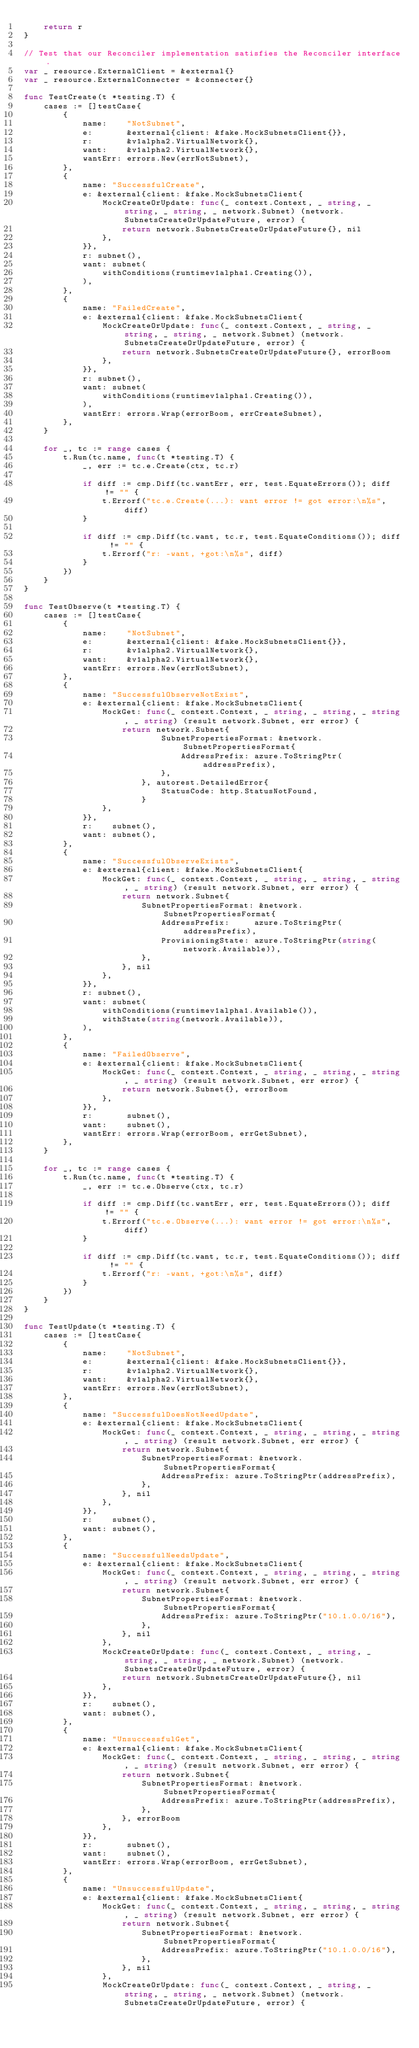Convert code to text. <code><loc_0><loc_0><loc_500><loc_500><_Go_>	return r
}

// Test that our Reconciler implementation satisfies the Reconciler interface.
var _ resource.ExternalClient = &external{}
var _ resource.ExternalConnecter = &connecter{}

func TestCreate(t *testing.T) {
	cases := []testCase{
		{
			name:    "NotSubnet",
			e:       &external{client: &fake.MockSubnetsClient{}},
			r:       &v1alpha2.VirtualNetwork{},
			want:    &v1alpha2.VirtualNetwork{},
			wantErr: errors.New(errNotSubnet),
		},
		{
			name: "SuccessfulCreate",
			e: &external{client: &fake.MockSubnetsClient{
				MockCreateOrUpdate: func(_ context.Context, _ string, _ string, _ string, _ network.Subnet) (network.SubnetsCreateOrUpdateFuture, error) {
					return network.SubnetsCreateOrUpdateFuture{}, nil
				},
			}},
			r: subnet(),
			want: subnet(
				withConditions(runtimev1alpha1.Creating()),
			),
		},
		{
			name: "FailedCreate",
			e: &external{client: &fake.MockSubnetsClient{
				MockCreateOrUpdate: func(_ context.Context, _ string, _ string, _ string, _ network.Subnet) (network.SubnetsCreateOrUpdateFuture, error) {
					return network.SubnetsCreateOrUpdateFuture{}, errorBoom
				},
			}},
			r: subnet(),
			want: subnet(
				withConditions(runtimev1alpha1.Creating()),
			),
			wantErr: errors.Wrap(errorBoom, errCreateSubnet),
		},
	}

	for _, tc := range cases {
		t.Run(tc.name, func(t *testing.T) {
			_, err := tc.e.Create(ctx, tc.r)

			if diff := cmp.Diff(tc.wantErr, err, test.EquateErrors()); diff != "" {
				t.Errorf("tc.e.Create(...): want error != got error:\n%s", diff)
			}

			if diff := cmp.Diff(tc.want, tc.r, test.EquateConditions()); diff != "" {
				t.Errorf("r: -want, +got:\n%s", diff)
			}
		})
	}
}

func TestObserve(t *testing.T) {
	cases := []testCase{
		{
			name:    "NotSubnet",
			e:       &external{client: &fake.MockSubnetsClient{}},
			r:       &v1alpha2.VirtualNetwork{},
			want:    &v1alpha2.VirtualNetwork{},
			wantErr: errors.New(errNotSubnet),
		},
		{
			name: "SuccessfulObserveNotExist",
			e: &external{client: &fake.MockSubnetsClient{
				MockGet: func(_ context.Context, _ string, _ string, _ string, _ string) (result network.Subnet, err error) {
					return network.Subnet{
							SubnetPropertiesFormat: &network.SubnetPropertiesFormat{
								AddressPrefix: azure.ToStringPtr(addressPrefix),
							},
						}, autorest.DetailedError{
							StatusCode: http.StatusNotFound,
						}
				},
			}},
			r:    subnet(),
			want: subnet(),
		},
		{
			name: "SuccessfulObserveExists",
			e: &external{client: &fake.MockSubnetsClient{
				MockGet: func(_ context.Context, _ string, _ string, _ string, _ string) (result network.Subnet, err error) {
					return network.Subnet{
						SubnetPropertiesFormat: &network.SubnetPropertiesFormat{
							AddressPrefix:     azure.ToStringPtr(addressPrefix),
							ProvisioningState: azure.ToStringPtr(string(network.Available)),
						},
					}, nil
				},
			}},
			r: subnet(),
			want: subnet(
				withConditions(runtimev1alpha1.Available()),
				withState(string(network.Available)),
			),
		},
		{
			name: "FailedObserve",
			e: &external{client: &fake.MockSubnetsClient{
				MockGet: func(_ context.Context, _ string, _ string, _ string, _ string) (result network.Subnet, err error) {
					return network.Subnet{}, errorBoom
				},
			}},
			r:       subnet(),
			want:    subnet(),
			wantErr: errors.Wrap(errorBoom, errGetSubnet),
		},
	}

	for _, tc := range cases {
		t.Run(tc.name, func(t *testing.T) {
			_, err := tc.e.Observe(ctx, tc.r)

			if diff := cmp.Diff(tc.wantErr, err, test.EquateErrors()); diff != "" {
				t.Errorf("tc.e.Observe(...): want error != got error:\n%s", diff)
			}

			if diff := cmp.Diff(tc.want, tc.r, test.EquateConditions()); diff != "" {
				t.Errorf("r: -want, +got:\n%s", diff)
			}
		})
	}
}

func TestUpdate(t *testing.T) {
	cases := []testCase{
		{
			name:    "NotSubnet",
			e:       &external{client: &fake.MockSubnetsClient{}},
			r:       &v1alpha2.VirtualNetwork{},
			want:    &v1alpha2.VirtualNetwork{},
			wantErr: errors.New(errNotSubnet),
		},
		{
			name: "SuccessfulDoesNotNeedUpdate",
			e: &external{client: &fake.MockSubnetsClient{
				MockGet: func(_ context.Context, _ string, _ string, _ string, _ string) (result network.Subnet, err error) {
					return network.Subnet{
						SubnetPropertiesFormat: &network.SubnetPropertiesFormat{
							AddressPrefix: azure.ToStringPtr(addressPrefix),
						},
					}, nil
				},
			}},
			r:    subnet(),
			want: subnet(),
		},
		{
			name: "SuccessfulNeedsUpdate",
			e: &external{client: &fake.MockSubnetsClient{
				MockGet: func(_ context.Context, _ string, _ string, _ string, _ string) (result network.Subnet, err error) {
					return network.Subnet{
						SubnetPropertiesFormat: &network.SubnetPropertiesFormat{
							AddressPrefix: azure.ToStringPtr("10.1.0.0/16"),
						},
					}, nil
				},
				MockCreateOrUpdate: func(_ context.Context, _ string, _ string, _ string, _ network.Subnet) (network.SubnetsCreateOrUpdateFuture, error) {
					return network.SubnetsCreateOrUpdateFuture{}, nil
				},
			}},
			r:    subnet(),
			want: subnet(),
		},
		{
			name: "UnsuccessfulGet",
			e: &external{client: &fake.MockSubnetsClient{
				MockGet: func(_ context.Context, _ string, _ string, _ string, _ string) (result network.Subnet, err error) {
					return network.Subnet{
						SubnetPropertiesFormat: &network.SubnetPropertiesFormat{
							AddressPrefix: azure.ToStringPtr(addressPrefix),
						},
					}, errorBoom
				},
			}},
			r:       subnet(),
			want:    subnet(),
			wantErr: errors.Wrap(errorBoom, errGetSubnet),
		},
		{
			name: "UnsuccessfulUpdate",
			e: &external{client: &fake.MockSubnetsClient{
				MockGet: func(_ context.Context, _ string, _ string, _ string, _ string) (result network.Subnet, err error) {
					return network.Subnet{
						SubnetPropertiesFormat: &network.SubnetPropertiesFormat{
							AddressPrefix: azure.ToStringPtr("10.1.0.0/16"),
						},
					}, nil
				},
				MockCreateOrUpdate: func(_ context.Context, _ string, _ string, _ string, _ network.Subnet) (network.SubnetsCreateOrUpdateFuture, error) {</code> 